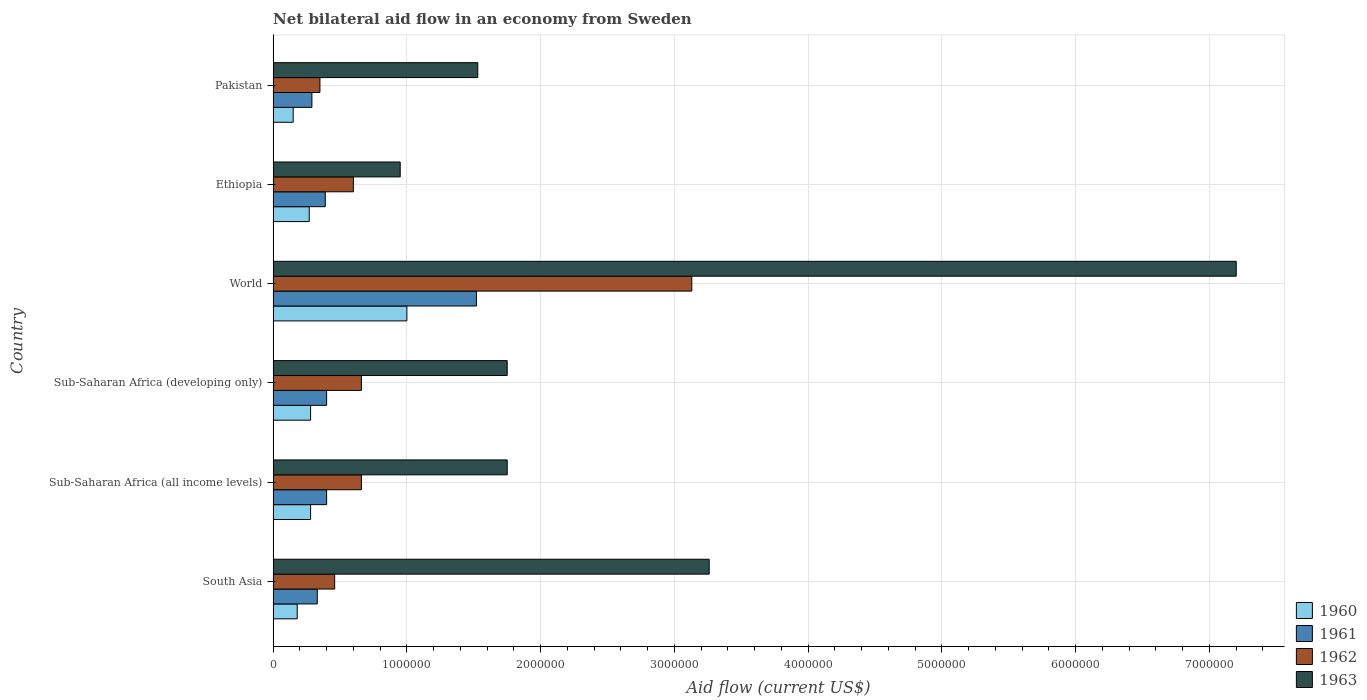How many different coloured bars are there?
Keep it short and to the point. 4. How many groups of bars are there?
Keep it short and to the point. 6. Are the number of bars per tick equal to the number of legend labels?
Your answer should be very brief. Yes. Are the number of bars on each tick of the Y-axis equal?
Your answer should be very brief. Yes. What is the label of the 4th group of bars from the top?
Offer a terse response. Sub-Saharan Africa (developing only). In how many cases, is the number of bars for a given country not equal to the number of legend labels?
Ensure brevity in your answer.  0. What is the net bilateral aid flow in 1963 in Pakistan?
Keep it short and to the point. 1.53e+06. Across all countries, what is the maximum net bilateral aid flow in 1960?
Your response must be concise. 1.00e+06. Across all countries, what is the minimum net bilateral aid flow in 1961?
Give a very brief answer. 2.90e+05. In which country was the net bilateral aid flow in 1962 minimum?
Keep it short and to the point. Pakistan. What is the total net bilateral aid flow in 1962 in the graph?
Your answer should be compact. 5.86e+06. What is the average net bilateral aid flow in 1963 per country?
Provide a succinct answer. 2.74e+06. What is the difference between the net bilateral aid flow in 1963 and net bilateral aid flow in 1960 in World?
Provide a short and direct response. 6.20e+06. In how many countries, is the net bilateral aid flow in 1960 greater than 2200000 US$?
Provide a succinct answer. 0. What is the ratio of the net bilateral aid flow in 1961 in Sub-Saharan Africa (all income levels) to that in World?
Your answer should be compact. 0.26. Is the difference between the net bilateral aid flow in 1963 in Pakistan and World greater than the difference between the net bilateral aid flow in 1960 in Pakistan and World?
Offer a very short reply. No. What is the difference between the highest and the second highest net bilateral aid flow in 1962?
Give a very brief answer. 2.47e+06. What is the difference between the highest and the lowest net bilateral aid flow in 1960?
Offer a terse response. 8.50e+05. In how many countries, is the net bilateral aid flow in 1961 greater than the average net bilateral aid flow in 1961 taken over all countries?
Provide a succinct answer. 1. Is the sum of the net bilateral aid flow in 1960 in Ethiopia and Sub-Saharan Africa (all income levels) greater than the maximum net bilateral aid flow in 1961 across all countries?
Your response must be concise. No. Is it the case that in every country, the sum of the net bilateral aid flow in 1960 and net bilateral aid flow in 1962 is greater than the net bilateral aid flow in 1961?
Offer a terse response. Yes. What is the difference between two consecutive major ticks on the X-axis?
Offer a terse response. 1.00e+06. Where does the legend appear in the graph?
Offer a terse response. Bottom right. How many legend labels are there?
Offer a very short reply. 4. How are the legend labels stacked?
Provide a short and direct response. Vertical. What is the title of the graph?
Provide a short and direct response. Net bilateral aid flow in an economy from Sweden. What is the Aid flow (current US$) in 1963 in South Asia?
Your answer should be compact. 3.26e+06. What is the Aid flow (current US$) of 1960 in Sub-Saharan Africa (all income levels)?
Keep it short and to the point. 2.80e+05. What is the Aid flow (current US$) in 1962 in Sub-Saharan Africa (all income levels)?
Make the answer very short. 6.60e+05. What is the Aid flow (current US$) of 1963 in Sub-Saharan Africa (all income levels)?
Your response must be concise. 1.75e+06. What is the Aid flow (current US$) in 1960 in Sub-Saharan Africa (developing only)?
Offer a very short reply. 2.80e+05. What is the Aid flow (current US$) in 1963 in Sub-Saharan Africa (developing only)?
Provide a succinct answer. 1.75e+06. What is the Aid flow (current US$) of 1961 in World?
Keep it short and to the point. 1.52e+06. What is the Aid flow (current US$) of 1962 in World?
Your answer should be compact. 3.13e+06. What is the Aid flow (current US$) of 1963 in World?
Your response must be concise. 7.20e+06. What is the Aid flow (current US$) in 1962 in Ethiopia?
Keep it short and to the point. 6.00e+05. What is the Aid flow (current US$) in 1963 in Ethiopia?
Offer a terse response. 9.50e+05. What is the Aid flow (current US$) in 1960 in Pakistan?
Ensure brevity in your answer.  1.50e+05. What is the Aid flow (current US$) in 1962 in Pakistan?
Offer a terse response. 3.50e+05. What is the Aid flow (current US$) in 1963 in Pakistan?
Your answer should be very brief. 1.53e+06. Across all countries, what is the maximum Aid flow (current US$) in 1960?
Keep it short and to the point. 1.00e+06. Across all countries, what is the maximum Aid flow (current US$) in 1961?
Keep it short and to the point. 1.52e+06. Across all countries, what is the maximum Aid flow (current US$) of 1962?
Offer a terse response. 3.13e+06. Across all countries, what is the maximum Aid flow (current US$) of 1963?
Offer a terse response. 7.20e+06. Across all countries, what is the minimum Aid flow (current US$) in 1962?
Keep it short and to the point. 3.50e+05. Across all countries, what is the minimum Aid flow (current US$) of 1963?
Keep it short and to the point. 9.50e+05. What is the total Aid flow (current US$) in 1960 in the graph?
Give a very brief answer. 2.16e+06. What is the total Aid flow (current US$) of 1961 in the graph?
Ensure brevity in your answer.  3.33e+06. What is the total Aid flow (current US$) of 1962 in the graph?
Provide a succinct answer. 5.86e+06. What is the total Aid flow (current US$) in 1963 in the graph?
Provide a succinct answer. 1.64e+07. What is the difference between the Aid flow (current US$) of 1960 in South Asia and that in Sub-Saharan Africa (all income levels)?
Make the answer very short. -1.00e+05. What is the difference between the Aid flow (current US$) of 1963 in South Asia and that in Sub-Saharan Africa (all income levels)?
Your answer should be very brief. 1.51e+06. What is the difference between the Aid flow (current US$) in 1961 in South Asia and that in Sub-Saharan Africa (developing only)?
Offer a terse response. -7.00e+04. What is the difference between the Aid flow (current US$) of 1962 in South Asia and that in Sub-Saharan Africa (developing only)?
Make the answer very short. -2.00e+05. What is the difference between the Aid flow (current US$) of 1963 in South Asia and that in Sub-Saharan Africa (developing only)?
Offer a terse response. 1.51e+06. What is the difference between the Aid flow (current US$) of 1960 in South Asia and that in World?
Provide a succinct answer. -8.20e+05. What is the difference between the Aid flow (current US$) in 1961 in South Asia and that in World?
Offer a terse response. -1.19e+06. What is the difference between the Aid flow (current US$) in 1962 in South Asia and that in World?
Your response must be concise. -2.67e+06. What is the difference between the Aid flow (current US$) in 1963 in South Asia and that in World?
Provide a short and direct response. -3.94e+06. What is the difference between the Aid flow (current US$) of 1962 in South Asia and that in Ethiopia?
Make the answer very short. -1.40e+05. What is the difference between the Aid flow (current US$) of 1963 in South Asia and that in Ethiopia?
Offer a terse response. 2.31e+06. What is the difference between the Aid flow (current US$) in 1960 in South Asia and that in Pakistan?
Your response must be concise. 3.00e+04. What is the difference between the Aid flow (current US$) of 1962 in South Asia and that in Pakistan?
Offer a terse response. 1.10e+05. What is the difference between the Aid flow (current US$) of 1963 in South Asia and that in Pakistan?
Ensure brevity in your answer.  1.73e+06. What is the difference between the Aid flow (current US$) of 1960 in Sub-Saharan Africa (all income levels) and that in Sub-Saharan Africa (developing only)?
Provide a succinct answer. 0. What is the difference between the Aid flow (current US$) of 1961 in Sub-Saharan Africa (all income levels) and that in Sub-Saharan Africa (developing only)?
Your answer should be very brief. 0. What is the difference between the Aid flow (current US$) in 1963 in Sub-Saharan Africa (all income levels) and that in Sub-Saharan Africa (developing only)?
Provide a succinct answer. 0. What is the difference between the Aid flow (current US$) in 1960 in Sub-Saharan Africa (all income levels) and that in World?
Your answer should be compact. -7.20e+05. What is the difference between the Aid flow (current US$) in 1961 in Sub-Saharan Africa (all income levels) and that in World?
Make the answer very short. -1.12e+06. What is the difference between the Aid flow (current US$) in 1962 in Sub-Saharan Africa (all income levels) and that in World?
Provide a succinct answer. -2.47e+06. What is the difference between the Aid flow (current US$) in 1963 in Sub-Saharan Africa (all income levels) and that in World?
Offer a very short reply. -5.45e+06. What is the difference between the Aid flow (current US$) in 1961 in Sub-Saharan Africa (all income levels) and that in Ethiopia?
Your answer should be very brief. 10000. What is the difference between the Aid flow (current US$) of 1962 in Sub-Saharan Africa (all income levels) and that in Ethiopia?
Keep it short and to the point. 6.00e+04. What is the difference between the Aid flow (current US$) in 1962 in Sub-Saharan Africa (all income levels) and that in Pakistan?
Your response must be concise. 3.10e+05. What is the difference between the Aid flow (current US$) of 1960 in Sub-Saharan Africa (developing only) and that in World?
Your answer should be compact. -7.20e+05. What is the difference between the Aid flow (current US$) in 1961 in Sub-Saharan Africa (developing only) and that in World?
Ensure brevity in your answer.  -1.12e+06. What is the difference between the Aid flow (current US$) in 1962 in Sub-Saharan Africa (developing only) and that in World?
Provide a succinct answer. -2.47e+06. What is the difference between the Aid flow (current US$) in 1963 in Sub-Saharan Africa (developing only) and that in World?
Ensure brevity in your answer.  -5.45e+06. What is the difference between the Aid flow (current US$) of 1961 in Sub-Saharan Africa (developing only) and that in Ethiopia?
Keep it short and to the point. 10000. What is the difference between the Aid flow (current US$) in 1963 in Sub-Saharan Africa (developing only) and that in Ethiopia?
Your response must be concise. 8.00e+05. What is the difference between the Aid flow (current US$) in 1960 in World and that in Ethiopia?
Your response must be concise. 7.30e+05. What is the difference between the Aid flow (current US$) of 1961 in World and that in Ethiopia?
Your answer should be compact. 1.13e+06. What is the difference between the Aid flow (current US$) in 1962 in World and that in Ethiopia?
Give a very brief answer. 2.53e+06. What is the difference between the Aid flow (current US$) of 1963 in World and that in Ethiopia?
Ensure brevity in your answer.  6.25e+06. What is the difference between the Aid flow (current US$) of 1960 in World and that in Pakistan?
Provide a succinct answer. 8.50e+05. What is the difference between the Aid flow (current US$) of 1961 in World and that in Pakistan?
Provide a succinct answer. 1.23e+06. What is the difference between the Aid flow (current US$) in 1962 in World and that in Pakistan?
Give a very brief answer. 2.78e+06. What is the difference between the Aid flow (current US$) in 1963 in World and that in Pakistan?
Make the answer very short. 5.67e+06. What is the difference between the Aid flow (current US$) in 1963 in Ethiopia and that in Pakistan?
Give a very brief answer. -5.80e+05. What is the difference between the Aid flow (current US$) of 1960 in South Asia and the Aid flow (current US$) of 1961 in Sub-Saharan Africa (all income levels)?
Give a very brief answer. -2.20e+05. What is the difference between the Aid flow (current US$) of 1960 in South Asia and the Aid flow (current US$) of 1962 in Sub-Saharan Africa (all income levels)?
Give a very brief answer. -4.80e+05. What is the difference between the Aid flow (current US$) of 1960 in South Asia and the Aid flow (current US$) of 1963 in Sub-Saharan Africa (all income levels)?
Your response must be concise. -1.57e+06. What is the difference between the Aid flow (current US$) of 1961 in South Asia and the Aid flow (current US$) of 1962 in Sub-Saharan Africa (all income levels)?
Your response must be concise. -3.30e+05. What is the difference between the Aid flow (current US$) of 1961 in South Asia and the Aid flow (current US$) of 1963 in Sub-Saharan Africa (all income levels)?
Offer a terse response. -1.42e+06. What is the difference between the Aid flow (current US$) in 1962 in South Asia and the Aid flow (current US$) in 1963 in Sub-Saharan Africa (all income levels)?
Keep it short and to the point. -1.29e+06. What is the difference between the Aid flow (current US$) in 1960 in South Asia and the Aid flow (current US$) in 1961 in Sub-Saharan Africa (developing only)?
Make the answer very short. -2.20e+05. What is the difference between the Aid flow (current US$) of 1960 in South Asia and the Aid flow (current US$) of 1962 in Sub-Saharan Africa (developing only)?
Your answer should be very brief. -4.80e+05. What is the difference between the Aid flow (current US$) of 1960 in South Asia and the Aid flow (current US$) of 1963 in Sub-Saharan Africa (developing only)?
Ensure brevity in your answer.  -1.57e+06. What is the difference between the Aid flow (current US$) of 1961 in South Asia and the Aid flow (current US$) of 1962 in Sub-Saharan Africa (developing only)?
Your response must be concise. -3.30e+05. What is the difference between the Aid flow (current US$) of 1961 in South Asia and the Aid flow (current US$) of 1963 in Sub-Saharan Africa (developing only)?
Make the answer very short. -1.42e+06. What is the difference between the Aid flow (current US$) of 1962 in South Asia and the Aid flow (current US$) of 1963 in Sub-Saharan Africa (developing only)?
Your answer should be compact. -1.29e+06. What is the difference between the Aid flow (current US$) in 1960 in South Asia and the Aid flow (current US$) in 1961 in World?
Provide a succinct answer. -1.34e+06. What is the difference between the Aid flow (current US$) in 1960 in South Asia and the Aid flow (current US$) in 1962 in World?
Ensure brevity in your answer.  -2.95e+06. What is the difference between the Aid flow (current US$) in 1960 in South Asia and the Aid flow (current US$) in 1963 in World?
Your response must be concise. -7.02e+06. What is the difference between the Aid flow (current US$) in 1961 in South Asia and the Aid flow (current US$) in 1962 in World?
Provide a short and direct response. -2.80e+06. What is the difference between the Aid flow (current US$) of 1961 in South Asia and the Aid flow (current US$) of 1963 in World?
Offer a terse response. -6.87e+06. What is the difference between the Aid flow (current US$) of 1962 in South Asia and the Aid flow (current US$) of 1963 in World?
Offer a very short reply. -6.74e+06. What is the difference between the Aid flow (current US$) in 1960 in South Asia and the Aid flow (current US$) in 1962 in Ethiopia?
Keep it short and to the point. -4.20e+05. What is the difference between the Aid flow (current US$) in 1960 in South Asia and the Aid flow (current US$) in 1963 in Ethiopia?
Offer a very short reply. -7.70e+05. What is the difference between the Aid flow (current US$) in 1961 in South Asia and the Aid flow (current US$) in 1962 in Ethiopia?
Offer a very short reply. -2.70e+05. What is the difference between the Aid flow (current US$) in 1961 in South Asia and the Aid flow (current US$) in 1963 in Ethiopia?
Ensure brevity in your answer.  -6.20e+05. What is the difference between the Aid flow (current US$) of 1962 in South Asia and the Aid flow (current US$) of 1963 in Ethiopia?
Offer a very short reply. -4.90e+05. What is the difference between the Aid flow (current US$) of 1960 in South Asia and the Aid flow (current US$) of 1961 in Pakistan?
Offer a very short reply. -1.10e+05. What is the difference between the Aid flow (current US$) of 1960 in South Asia and the Aid flow (current US$) of 1963 in Pakistan?
Make the answer very short. -1.35e+06. What is the difference between the Aid flow (current US$) of 1961 in South Asia and the Aid flow (current US$) of 1963 in Pakistan?
Your response must be concise. -1.20e+06. What is the difference between the Aid flow (current US$) in 1962 in South Asia and the Aid flow (current US$) in 1963 in Pakistan?
Give a very brief answer. -1.07e+06. What is the difference between the Aid flow (current US$) in 1960 in Sub-Saharan Africa (all income levels) and the Aid flow (current US$) in 1962 in Sub-Saharan Africa (developing only)?
Make the answer very short. -3.80e+05. What is the difference between the Aid flow (current US$) in 1960 in Sub-Saharan Africa (all income levels) and the Aid flow (current US$) in 1963 in Sub-Saharan Africa (developing only)?
Your response must be concise. -1.47e+06. What is the difference between the Aid flow (current US$) of 1961 in Sub-Saharan Africa (all income levels) and the Aid flow (current US$) of 1963 in Sub-Saharan Africa (developing only)?
Provide a succinct answer. -1.35e+06. What is the difference between the Aid flow (current US$) of 1962 in Sub-Saharan Africa (all income levels) and the Aid flow (current US$) of 1963 in Sub-Saharan Africa (developing only)?
Your answer should be very brief. -1.09e+06. What is the difference between the Aid flow (current US$) of 1960 in Sub-Saharan Africa (all income levels) and the Aid flow (current US$) of 1961 in World?
Your response must be concise. -1.24e+06. What is the difference between the Aid flow (current US$) of 1960 in Sub-Saharan Africa (all income levels) and the Aid flow (current US$) of 1962 in World?
Your response must be concise. -2.85e+06. What is the difference between the Aid flow (current US$) in 1960 in Sub-Saharan Africa (all income levels) and the Aid flow (current US$) in 1963 in World?
Offer a very short reply. -6.92e+06. What is the difference between the Aid flow (current US$) in 1961 in Sub-Saharan Africa (all income levels) and the Aid flow (current US$) in 1962 in World?
Your answer should be compact. -2.73e+06. What is the difference between the Aid flow (current US$) in 1961 in Sub-Saharan Africa (all income levels) and the Aid flow (current US$) in 1963 in World?
Provide a short and direct response. -6.80e+06. What is the difference between the Aid flow (current US$) in 1962 in Sub-Saharan Africa (all income levels) and the Aid flow (current US$) in 1963 in World?
Offer a terse response. -6.54e+06. What is the difference between the Aid flow (current US$) of 1960 in Sub-Saharan Africa (all income levels) and the Aid flow (current US$) of 1961 in Ethiopia?
Offer a terse response. -1.10e+05. What is the difference between the Aid flow (current US$) of 1960 in Sub-Saharan Africa (all income levels) and the Aid flow (current US$) of 1962 in Ethiopia?
Your response must be concise. -3.20e+05. What is the difference between the Aid flow (current US$) in 1960 in Sub-Saharan Africa (all income levels) and the Aid flow (current US$) in 1963 in Ethiopia?
Your answer should be compact. -6.70e+05. What is the difference between the Aid flow (current US$) of 1961 in Sub-Saharan Africa (all income levels) and the Aid flow (current US$) of 1962 in Ethiopia?
Provide a short and direct response. -2.00e+05. What is the difference between the Aid flow (current US$) of 1961 in Sub-Saharan Africa (all income levels) and the Aid flow (current US$) of 1963 in Ethiopia?
Make the answer very short. -5.50e+05. What is the difference between the Aid flow (current US$) of 1962 in Sub-Saharan Africa (all income levels) and the Aid flow (current US$) of 1963 in Ethiopia?
Your response must be concise. -2.90e+05. What is the difference between the Aid flow (current US$) in 1960 in Sub-Saharan Africa (all income levels) and the Aid flow (current US$) in 1961 in Pakistan?
Provide a succinct answer. -10000. What is the difference between the Aid flow (current US$) in 1960 in Sub-Saharan Africa (all income levels) and the Aid flow (current US$) in 1962 in Pakistan?
Make the answer very short. -7.00e+04. What is the difference between the Aid flow (current US$) in 1960 in Sub-Saharan Africa (all income levels) and the Aid flow (current US$) in 1963 in Pakistan?
Your response must be concise. -1.25e+06. What is the difference between the Aid flow (current US$) in 1961 in Sub-Saharan Africa (all income levels) and the Aid flow (current US$) in 1962 in Pakistan?
Provide a succinct answer. 5.00e+04. What is the difference between the Aid flow (current US$) of 1961 in Sub-Saharan Africa (all income levels) and the Aid flow (current US$) of 1963 in Pakistan?
Ensure brevity in your answer.  -1.13e+06. What is the difference between the Aid flow (current US$) in 1962 in Sub-Saharan Africa (all income levels) and the Aid flow (current US$) in 1963 in Pakistan?
Give a very brief answer. -8.70e+05. What is the difference between the Aid flow (current US$) in 1960 in Sub-Saharan Africa (developing only) and the Aid flow (current US$) in 1961 in World?
Offer a terse response. -1.24e+06. What is the difference between the Aid flow (current US$) in 1960 in Sub-Saharan Africa (developing only) and the Aid flow (current US$) in 1962 in World?
Make the answer very short. -2.85e+06. What is the difference between the Aid flow (current US$) of 1960 in Sub-Saharan Africa (developing only) and the Aid flow (current US$) of 1963 in World?
Offer a terse response. -6.92e+06. What is the difference between the Aid flow (current US$) in 1961 in Sub-Saharan Africa (developing only) and the Aid flow (current US$) in 1962 in World?
Provide a short and direct response. -2.73e+06. What is the difference between the Aid flow (current US$) of 1961 in Sub-Saharan Africa (developing only) and the Aid flow (current US$) of 1963 in World?
Your response must be concise. -6.80e+06. What is the difference between the Aid flow (current US$) of 1962 in Sub-Saharan Africa (developing only) and the Aid flow (current US$) of 1963 in World?
Your answer should be compact. -6.54e+06. What is the difference between the Aid flow (current US$) of 1960 in Sub-Saharan Africa (developing only) and the Aid flow (current US$) of 1962 in Ethiopia?
Provide a short and direct response. -3.20e+05. What is the difference between the Aid flow (current US$) of 1960 in Sub-Saharan Africa (developing only) and the Aid flow (current US$) of 1963 in Ethiopia?
Your response must be concise. -6.70e+05. What is the difference between the Aid flow (current US$) of 1961 in Sub-Saharan Africa (developing only) and the Aid flow (current US$) of 1963 in Ethiopia?
Your response must be concise. -5.50e+05. What is the difference between the Aid flow (current US$) of 1960 in Sub-Saharan Africa (developing only) and the Aid flow (current US$) of 1961 in Pakistan?
Give a very brief answer. -10000. What is the difference between the Aid flow (current US$) in 1960 in Sub-Saharan Africa (developing only) and the Aid flow (current US$) in 1963 in Pakistan?
Offer a very short reply. -1.25e+06. What is the difference between the Aid flow (current US$) in 1961 in Sub-Saharan Africa (developing only) and the Aid flow (current US$) in 1962 in Pakistan?
Offer a very short reply. 5.00e+04. What is the difference between the Aid flow (current US$) of 1961 in Sub-Saharan Africa (developing only) and the Aid flow (current US$) of 1963 in Pakistan?
Your answer should be very brief. -1.13e+06. What is the difference between the Aid flow (current US$) in 1962 in Sub-Saharan Africa (developing only) and the Aid flow (current US$) in 1963 in Pakistan?
Ensure brevity in your answer.  -8.70e+05. What is the difference between the Aid flow (current US$) in 1960 in World and the Aid flow (current US$) in 1961 in Ethiopia?
Your response must be concise. 6.10e+05. What is the difference between the Aid flow (current US$) in 1960 in World and the Aid flow (current US$) in 1963 in Ethiopia?
Ensure brevity in your answer.  5.00e+04. What is the difference between the Aid flow (current US$) in 1961 in World and the Aid flow (current US$) in 1962 in Ethiopia?
Your answer should be compact. 9.20e+05. What is the difference between the Aid flow (current US$) of 1961 in World and the Aid flow (current US$) of 1963 in Ethiopia?
Your response must be concise. 5.70e+05. What is the difference between the Aid flow (current US$) in 1962 in World and the Aid flow (current US$) in 1963 in Ethiopia?
Give a very brief answer. 2.18e+06. What is the difference between the Aid flow (current US$) of 1960 in World and the Aid flow (current US$) of 1961 in Pakistan?
Provide a succinct answer. 7.10e+05. What is the difference between the Aid flow (current US$) of 1960 in World and the Aid flow (current US$) of 1962 in Pakistan?
Offer a terse response. 6.50e+05. What is the difference between the Aid flow (current US$) in 1960 in World and the Aid flow (current US$) in 1963 in Pakistan?
Give a very brief answer. -5.30e+05. What is the difference between the Aid flow (current US$) in 1961 in World and the Aid flow (current US$) in 1962 in Pakistan?
Offer a very short reply. 1.17e+06. What is the difference between the Aid flow (current US$) of 1962 in World and the Aid flow (current US$) of 1963 in Pakistan?
Your response must be concise. 1.60e+06. What is the difference between the Aid flow (current US$) of 1960 in Ethiopia and the Aid flow (current US$) of 1963 in Pakistan?
Your answer should be very brief. -1.26e+06. What is the difference between the Aid flow (current US$) in 1961 in Ethiopia and the Aid flow (current US$) in 1963 in Pakistan?
Make the answer very short. -1.14e+06. What is the difference between the Aid flow (current US$) of 1962 in Ethiopia and the Aid flow (current US$) of 1963 in Pakistan?
Offer a terse response. -9.30e+05. What is the average Aid flow (current US$) in 1961 per country?
Your answer should be very brief. 5.55e+05. What is the average Aid flow (current US$) in 1962 per country?
Offer a very short reply. 9.77e+05. What is the average Aid flow (current US$) of 1963 per country?
Keep it short and to the point. 2.74e+06. What is the difference between the Aid flow (current US$) of 1960 and Aid flow (current US$) of 1961 in South Asia?
Offer a terse response. -1.50e+05. What is the difference between the Aid flow (current US$) of 1960 and Aid flow (current US$) of 1962 in South Asia?
Ensure brevity in your answer.  -2.80e+05. What is the difference between the Aid flow (current US$) of 1960 and Aid flow (current US$) of 1963 in South Asia?
Ensure brevity in your answer.  -3.08e+06. What is the difference between the Aid flow (current US$) of 1961 and Aid flow (current US$) of 1963 in South Asia?
Provide a succinct answer. -2.93e+06. What is the difference between the Aid flow (current US$) in 1962 and Aid flow (current US$) in 1963 in South Asia?
Ensure brevity in your answer.  -2.80e+06. What is the difference between the Aid flow (current US$) of 1960 and Aid flow (current US$) of 1961 in Sub-Saharan Africa (all income levels)?
Your answer should be very brief. -1.20e+05. What is the difference between the Aid flow (current US$) of 1960 and Aid flow (current US$) of 1962 in Sub-Saharan Africa (all income levels)?
Your answer should be very brief. -3.80e+05. What is the difference between the Aid flow (current US$) of 1960 and Aid flow (current US$) of 1963 in Sub-Saharan Africa (all income levels)?
Keep it short and to the point. -1.47e+06. What is the difference between the Aid flow (current US$) of 1961 and Aid flow (current US$) of 1963 in Sub-Saharan Africa (all income levels)?
Your answer should be very brief. -1.35e+06. What is the difference between the Aid flow (current US$) of 1962 and Aid flow (current US$) of 1963 in Sub-Saharan Africa (all income levels)?
Make the answer very short. -1.09e+06. What is the difference between the Aid flow (current US$) of 1960 and Aid flow (current US$) of 1962 in Sub-Saharan Africa (developing only)?
Your answer should be very brief. -3.80e+05. What is the difference between the Aid flow (current US$) of 1960 and Aid flow (current US$) of 1963 in Sub-Saharan Africa (developing only)?
Ensure brevity in your answer.  -1.47e+06. What is the difference between the Aid flow (current US$) of 1961 and Aid flow (current US$) of 1963 in Sub-Saharan Africa (developing only)?
Give a very brief answer. -1.35e+06. What is the difference between the Aid flow (current US$) in 1962 and Aid flow (current US$) in 1963 in Sub-Saharan Africa (developing only)?
Give a very brief answer. -1.09e+06. What is the difference between the Aid flow (current US$) in 1960 and Aid flow (current US$) in 1961 in World?
Your answer should be very brief. -5.20e+05. What is the difference between the Aid flow (current US$) in 1960 and Aid flow (current US$) in 1962 in World?
Your response must be concise. -2.13e+06. What is the difference between the Aid flow (current US$) of 1960 and Aid flow (current US$) of 1963 in World?
Your answer should be compact. -6.20e+06. What is the difference between the Aid flow (current US$) of 1961 and Aid flow (current US$) of 1962 in World?
Your answer should be compact. -1.61e+06. What is the difference between the Aid flow (current US$) of 1961 and Aid flow (current US$) of 1963 in World?
Provide a succinct answer. -5.68e+06. What is the difference between the Aid flow (current US$) in 1962 and Aid flow (current US$) in 1963 in World?
Your answer should be compact. -4.07e+06. What is the difference between the Aid flow (current US$) of 1960 and Aid flow (current US$) of 1962 in Ethiopia?
Offer a terse response. -3.30e+05. What is the difference between the Aid flow (current US$) of 1960 and Aid flow (current US$) of 1963 in Ethiopia?
Provide a succinct answer. -6.80e+05. What is the difference between the Aid flow (current US$) in 1961 and Aid flow (current US$) in 1962 in Ethiopia?
Keep it short and to the point. -2.10e+05. What is the difference between the Aid flow (current US$) of 1961 and Aid flow (current US$) of 1963 in Ethiopia?
Provide a short and direct response. -5.60e+05. What is the difference between the Aid flow (current US$) in 1962 and Aid flow (current US$) in 1963 in Ethiopia?
Offer a very short reply. -3.50e+05. What is the difference between the Aid flow (current US$) of 1960 and Aid flow (current US$) of 1962 in Pakistan?
Offer a very short reply. -2.00e+05. What is the difference between the Aid flow (current US$) in 1960 and Aid flow (current US$) in 1963 in Pakistan?
Your response must be concise. -1.38e+06. What is the difference between the Aid flow (current US$) in 1961 and Aid flow (current US$) in 1963 in Pakistan?
Offer a terse response. -1.24e+06. What is the difference between the Aid flow (current US$) in 1962 and Aid flow (current US$) in 1963 in Pakistan?
Your answer should be very brief. -1.18e+06. What is the ratio of the Aid flow (current US$) in 1960 in South Asia to that in Sub-Saharan Africa (all income levels)?
Your response must be concise. 0.64. What is the ratio of the Aid flow (current US$) in 1961 in South Asia to that in Sub-Saharan Africa (all income levels)?
Offer a terse response. 0.82. What is the ratio of the Aid flow (current US$) in 1962 in South Asia to that in Sub-Saharan Africa (all income levels)?
Give a very brief answer. 0.7. What is the ratio of the Aid flow (current US$) of 1963 in South Asia to that in Sub-Saharan Africa (all income levels)?
Provide a succinct answer. 1.86. What is the ratio of the Aid flow (current US$) of 1960 in South Asia to that in Sub-Saharan Africa (developing only)?
Your answer should be compact. 0.64. What is the ratio of the Aid flow (current US$) in 1961 in South Asia to that in Sub-Saharan Africa (developing only)?
Provide a succinct answer. 0.82. What is the ratio of the Aid flow (current US$) of 1962 in South Asia to that in Sub-Saharan Africa (developing only)?
Provide a short and direct response. 0.7. What is the ratio of the Aid flow (current US$) in 1963 in South Asia to that in Sub-Saharan Africa (developing only)?
Provide a succinct answer. 1.86. What is the ratio of the Aid flow (current US$) in 1960 in South Asia to that in World?
Your response must be concise. 0.18. What is the ratio of the Aid flow (current US$) of 1961 in South Asia to that in World?
Make the answer very short. 0.22. What is the ratio of the Aid flow (current US$) of 1962 in South Asia to that in World?
Offer a terse response. 0.15. What is the ratio of the Aid flow (current US$) in 1963 in South Asia to that in World?
Offer a terse response. 0.45. What is the ratio of the Aid flow (current US$) of 1960 in South Asia to that in Ethiopia?
Keep it short and to the point. 0.67. What is the ratio of the Aid flow (current US$) of 1961 in South Asia to that in Ethiopia?
Ensure brevity in your answer.  0.85. What is the ratio of the Aid flow (current US$) of 1962 in South Asia to that in Ethiopia?
Ensure brevity in your answer.  0.77. What is the ratio of the Aid flow (current US$) in 1963 in South Asia to that in Ethiopia?
Provide a succinct answer. 3.43. What is the ratio of the Aid flow (current US$) in 1961 in South Asia to that in Pakistan?
Give a very brief answer. 1.14. What is the ratio of the Aid flow (current US$) of 1962 in South Asia to that in Pakistan?
Give a very brief answer. 1.31. What is the ratio of the Aid flow (current US$) of 1963 in South Asia to that in Pakistan?
Make the answer very short. 2.13. What is the ratio of the Aid flow (current US$) of 1960 in Sub-Saharan Africa (all income levels) to that in Sub-Saharan Africa (developing only)?
Give a very brief answer. 1. What is the ratio of the Aid flow (current US$) of 1961 in Sub-Saharan Africa (all income levels) to that in Sub-Saharan Africa (developing only)?
Your answer should be compact. 1. What is the ratio of the Aid flow (current US$) of 1963 in Sub-Saharan Africa (all income levels) to that in Sub-Saharan Africa (developing only)?
Your response must be concise. 1. What is the ratio of the Aid flow (current US$) in 1960 in Sub-Saharan Africa (all income levels) to that in World?
Provide a succinct answer. 0.28. What is the ratio of the Aid flow (current US$) of 1961 in Sub-Saharan Africa (all income levels) to that in World?
Keep it short and to the point. 0.26. What is the ratio of the Aid flow (current US$) in 1962 in Sub-Saharan Africa (all income levels) to that in World?
Offer a terse response. 0.21. What is the ratio of the Aid flow (current US$) of 1963 in Sub-Saharan Africa (all income levels) to that in World?
Give a very brief answer. 0.24. What is the ratio of the Aid flow (current US$) in 1961 in Sub-Saharan Africa (all income levels) to that in Ethiopia?
Provide a succinct answer. 1.03. What is the ratio of the Aid flow (current US$) of 1962 in Sub-Saharan Africa (all income levels) to that in Ethiopia?
Keep it short and to the point. 1.1. What is the ratio of the Aid flow (current US$) of 1963 in Sub-Saharan Africa (all income levels) to that in Ethiopia?
Provide a succinct answer. 1.84. What is the ratio of the Aid flow (current US$) in 1960 in Sub-Saharan Africa (all income levels) to that in Pakistan?
Make the answer very short. 1.87. What is the ratio of the Aid flow (current US$) of 1961 in Sub-Saharan Africa (all income levels) to that in Pakistan?
Ensure brevity in your answer.  1.38. What is the ratio of the Aid flow (current US$) in 1962 in Sub-Saharan Africa (all income levels) to that in Pakistan?
Make the answer very short. 1.89. What is the ratio of the Aid flow (current US$) in 1963 in Sub-Saharan Africa (all income levels) to that in Pakistan?
Make the answer very short. 1.14. What is the ratio of the Aid flow (current US$) of 1960 in Sub-Saharan Africa (developing only) to that in World?
Keep it short and to the point. 0.28. What is the ratio of the Aid flow (current US$) of 1961 in Sub-Saharan Africa (developing only) to that in World?
Give a very brief answer. 0.26. What is the ratio of the Aid flow (current US$) of 1962 in Sub-Saharan Africa (developing only) to that in World?
Ensure brevity in your answer.  0.21. What is the ratio of the Aid flow (current US$) in 1963 in Sub-Saharan Africa (developing only) to that in World?
Your answer should be very brief. 0.24. What is the ratio of the Aid flow (current US$) of 1960 in Sub-Saharan Africa (developing only) to that in Ethiopia?
Offer a terse response. 1.04. What is the ratio of the Aid flow (current US$) in 1961 in Sub-Saharan Africa (developing only) to that in Ethiopia?
Offer a very short reply. 1.03. What is the ratio of the Aid flow (current US$) of 1962 in Sub-Saharan Africa (developing only) to that in Ethiopia?
Offer a terse response. 1.1. What is the ratio of the Aid flow (current US$) of 1963 in Sub-Saharan Africa (developing only) to that in Ethiopia?
Provide a short and direct response. 1.84. What is the ratio of the Aid flow (current US$) in 1960 in Sub-Saharan Africa (developing only) to that in Pakistan?
Make the answer very short. 1.87. What is the ratio of the Aid flow (current US$) in 1961 in Sub-Saharan Africa (developing only) to that in Pakistan?
Ensure brevity in your answer.  1.38. What is the ratio of the Aid flow (current US$) of 1962 in Sub-Saharan Africa (developing only) to that in Pakistan?
Offer a very short reply. 1.89. What is the ratio of the Aid flow (current US$) in 1963 in Sub-Saharan Africa (developing only) to that in Pakistan?
Your answer should be compact. 1.14. What is the ratio of the Aid flow (current US$) in 1960 in World to that in Ethiopia?
Keep it short and to the point. 3.7. What is the ratio of the Aid flow (current US$) of 1961 in World to that in Ethiopia?
Offer a terse response. 3.9. What is the ratio of the Aid flow (current US$) of 1962 in World to that in Ethiopia?
Ensure brevity in your answer.  5.22. What is the ratio of the Aid flow (current US$) of 1963 in World to that in Ethiopia?
Ensure brevity in your answer.  7.58. What is the ratio of the Aid flow (current US$) in 1960 in World to that in Pakistan?
Ensure brevity in your answer.  6.67. What is the ratio of the Aid flow (current US$) in 1961 in World to that in Pakistan?
Ensure brevity in your answer.  5.24. What is the ratio of the Aid flow (current US$) of 1962 in World to that in Pakistan?
Give a very brief answer. 8.94. What is the ratio of the Aid flow (current US$) of 1963 in World to that in Pakistan?
Your answer should be compact. 4.71. What is the ratio of the Aid flow (current US$) of 1961 in Ethiopia to that in Pakistan?
Give a very brief answer. 1.34. What is the ratio of the Aid flow (current US$) of 1962 in Ethiopia to that in Pakistan?
Keep it short and to the point. 1.71. What is the ratio of the Aid flow (current US$) in 1963 in Ethiopia to that in Pakistan?
Give a very brief answer. 0.62. What is the difference between the highest and the second highest Aid flow (current US$) of 1960?
Offer a terse response. 7.20e+05. What is the difference between the highest and the second highest Aid flow (current US$) in 1961?
Offer a very short reply. 1.12e+06. What is the difference between the highest and the second highest Aid flow (current US$) of 1962?
Your answer should be compact. 2.47e+06. What is the difference between the highest and the second highest Aid flow (current US$) in 1963?
Make the answer very short. 3.94e+06. What is the difference between the highest and the lowest Aid flow (current US$) in 1960?
Give a very brief answer. 8.50e+05. What is the difference between the highest and the lowest Aid flow (current US$) in 1961?
Provide a short and direct response. 1.23e+06. What is the difference between the highest and the lowest Aid flow (current US$) in 1962?
Provide a short and direct response. 2.78e+06. What is the difference between the highest and the lowest Aid flow (current US$) of 1963?
Ensure brevity in your answer.  6.25e+06. 